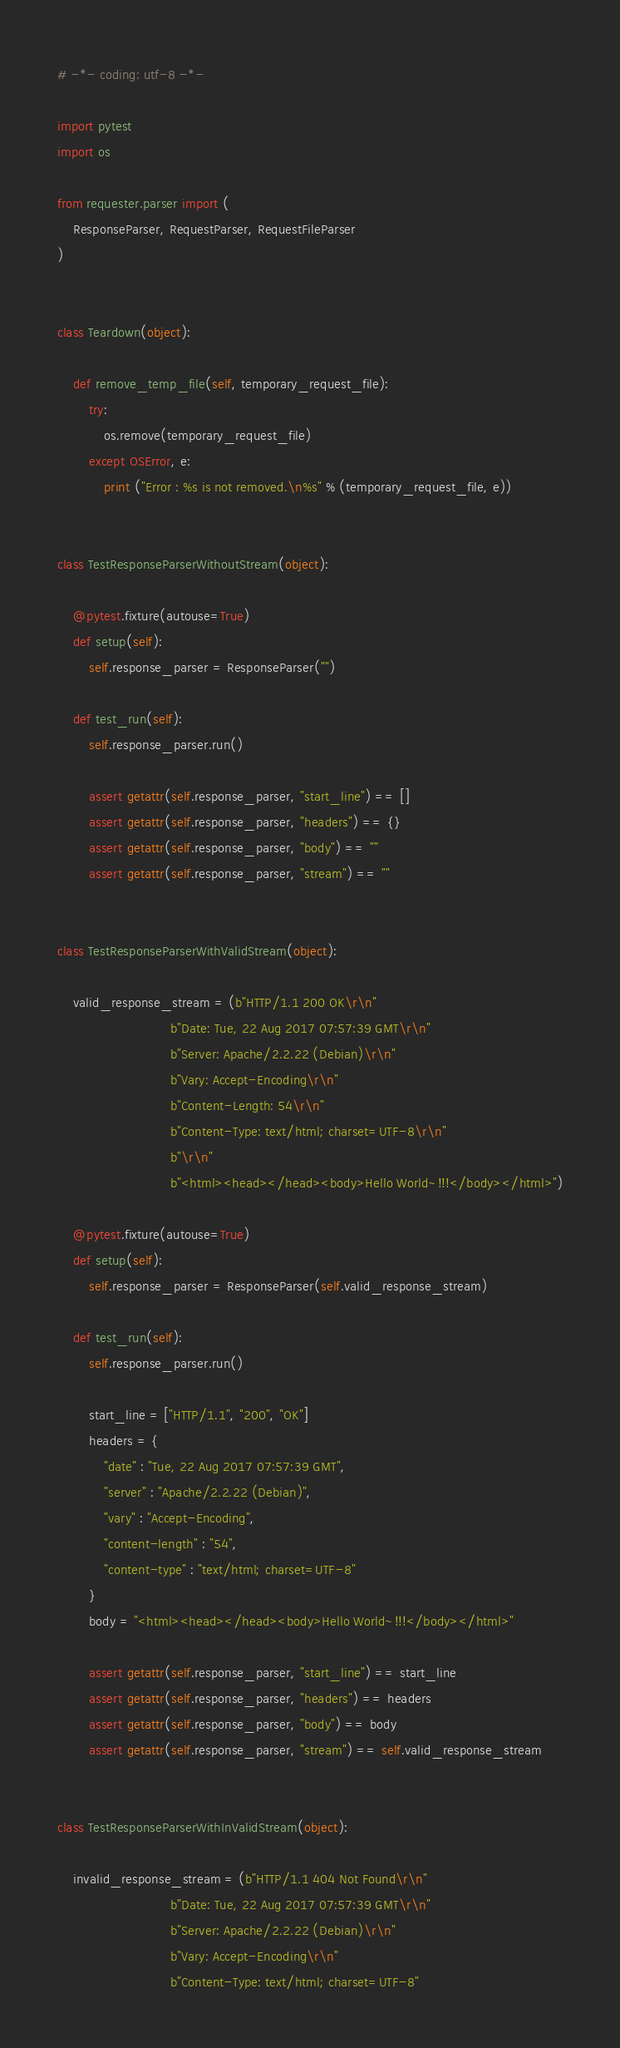<code> <loc_0><loc_0><loc_500><loc_500><_Python_># -*- coding: utf-8 -*-

import pytest
import os

from requester.parser import (
    ResponseParser, RequestParser, RequestFileParser
)


class Teardown(object):

    def remove_temp_file(self, temporary_request_file):
        try:
            os.remove(temporary_request_file)
        except OSError, e:
            print ("Error : %s is not removed.\n%s" % (temporary_request_file, e))


class TestResponseParserWithoutStream(object):

    @pytest.fixture(autouse=True)
    def setup(self):
        self.response_parser = ResponseParser("")

    def test_run(self):
        self.response_parser.run()

        assert getattr(self.response_parser, "start_line") == []
        assert getattr(self.response_parser, "headers") == {}
        assert getattr(self.response_parser, "body") == ""
        assert getattr(self.response_parser, "stream") == ""


class TestResponseParserWithValidStream(object):

    valid_response_stream = (b"HTTP/1.1 200 OK\r\n"
                             b"Date: Tue, 22 Aug 2017 07:57:39 GMT\r\n"
                             b"Server: Apache/2.2.22 (Debian)\r\n"
                             b"Vary: Accept-Encoding\r\n"
                             b"Content-Length: 54\r\n"
                             b"Content-Type: text/html; charset=UTF-8\r\n"
                             b"\r\n"
                             b"<html><head></head><body>Hello World~!!!</body></html>")

    @pytest.fixture(autouse=True)
    def setup(self):
        self.response_parser = ResponseParser(self.valid_response_stream)

    def test_run(self):
        self.response_parser.run()

        start_line = ["HTTP/1.1", "200", "OK"]
        headers = {
            "date" : "Tue, 22 Aug 2017 07:57:39 GMT",
            "server" : "Apache/2.2.22 (Debian)",
            "vary" : "Accept-Encoding",
            "content-length" : "54",
            "content-type" : "text/html; charset=UTF-8"
        }
        body = "<html><head></head><body>Hello World~!!!</body></html>"

        assert getattr(self.response_parser, "start_line") == start_line
        assert getattr(self.response_parser, "headers") == headers
        assert getattr(self.response_parser, "body") == body
        assert getattr(self.response_parser, "stream") == self.valid_response_stream


class TestResponseParserWithInValidStream(object):

    invalid_response_stream = (b"HTTP/1.1 404 Not Found\r\n"
                             b"Date: Tue, 22 Aug 2017 07:57:39 GMT\r\n"
                             b"Server: Apache/2.2.22 (Debian)\r\n"
                             b"Vary: Accept-Encoding\r\n"
                             b"Content-Type: text/html; charset=UTF-8"</code> 